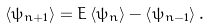<formula> <loc_0><loc_0><loc_500><loc_500>\left \langle \psi _ { n + 1 } \right \rangle = E \left \langle \psi _ { n } \right \rangle - \left \langle \psi _ { n - 1 } \right \rangle .</formula> 